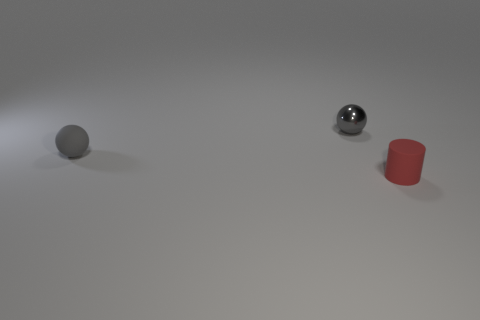Are there more balls that are to the left of the small red thing than tiny things on the right side of the small metal ball?
Your answer should be compact. Yes. Are there any small metal balls in front of the gray matte object?
Your answer should be very brief. No. Is there a gray ball that has the same size as the rubber cylinder?
Make the answer very short. Yes. The other object that is made of the same material as the red thing is what color?
Provide a short and direct response. Gray. What is the small red thing made of?
Your response must be concise. Rubber. There is a red rubber thing; what shape is it?
Offer a very short reply. Cylinder. How many other small cylinders are the same color as the rubber cylinder?
Make the answer very short. 0. There is a tiny gray sphere that is to the left of the small gray sphere behind the matte object that is left of the tiny red object; what is it made of?
Your response must be concise. Rubber. What number of gray things are either small shiny things or small matte things?
Offer a very short reply. 2. There is a rubber thing that is to the left of the tiny gray ball behind the tiny matte object behind the tiny red thing; how big is it?
Offer a terse response. Small. 